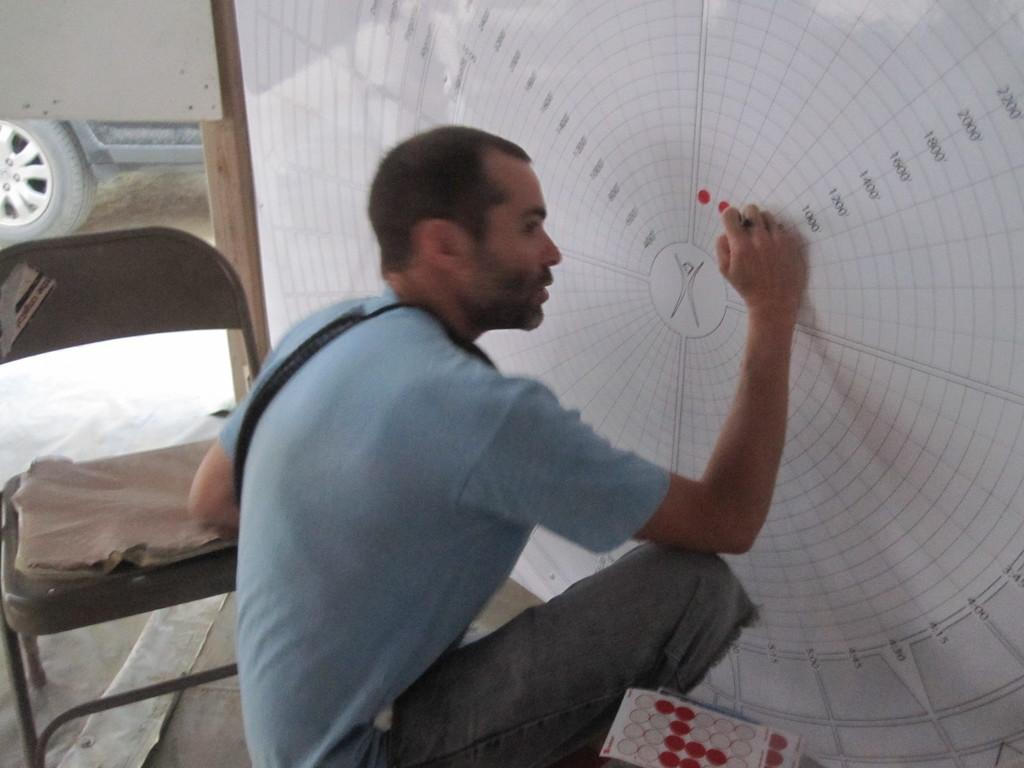What is the man in the image doing? The man is sitting in the image. What can be seen in the background of the image? There is a chair, a vehicle, a white color board, and other objects in the background of the image. Can you describe the chair in the background? The chair is in the background of the image, but its specific features are not mentioned in the facts. What type of vehicle is visible in the background? The type of vehicle is not specified in the facts. What type of waves can be seen in the image? There are no waves present in the image. Who is the father of the man in the image? The facts do not mention any information about the man's father. 